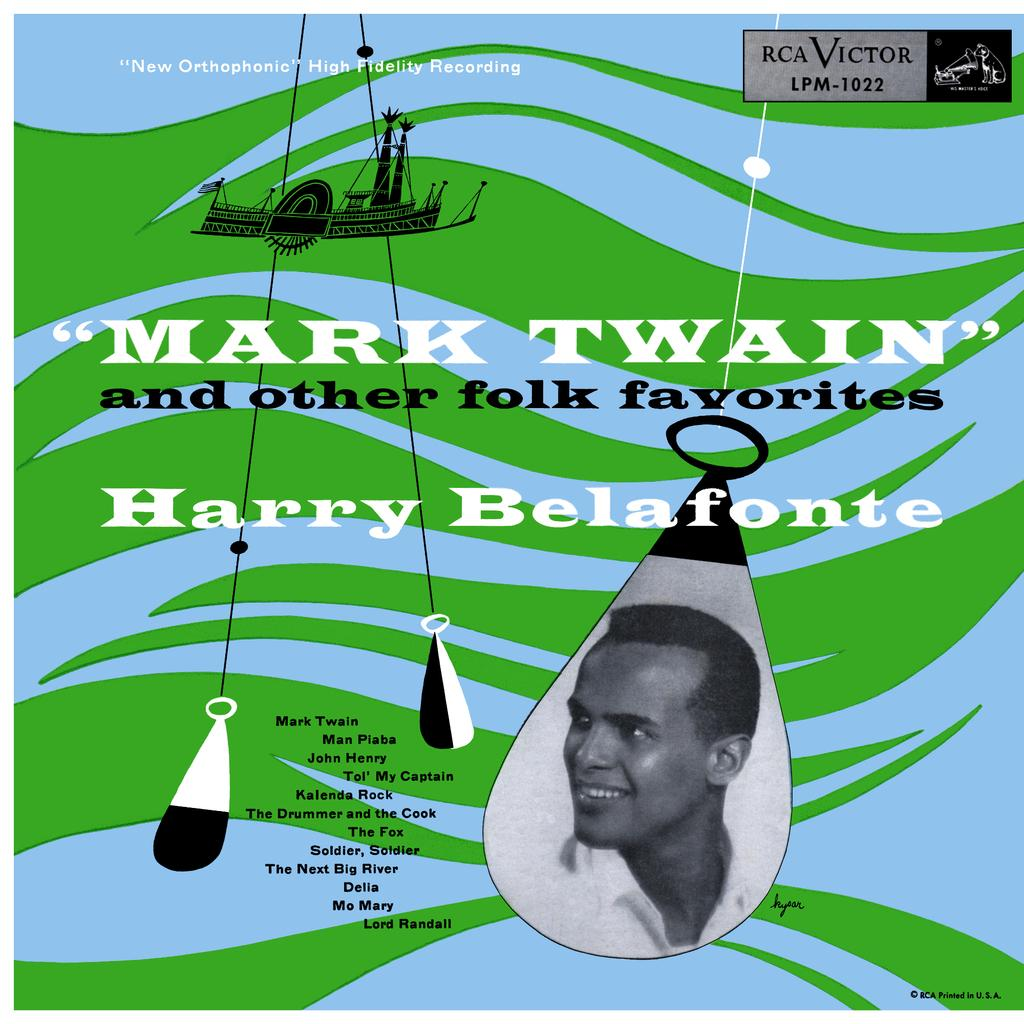What type of visual is the image? The image is a poster. What can be found on the poster besides visual elements? There are words on the poster. Are there any symbols or icons on the poster? Yes, there is a symbol on the poster. Is there a person depicted on the poster? Yes, there is a photo of a person on the poster. Can you describe any additional features of the image? There are watermarks on the image. What type of leaf is being used as a prop in the photo of the person on the poster? There is no leaf present in the photo of the person on the poster. Is there any water visible in the image? The presence of watermarks does not indicate visible water in the image; it is a watermark on the image itself. 